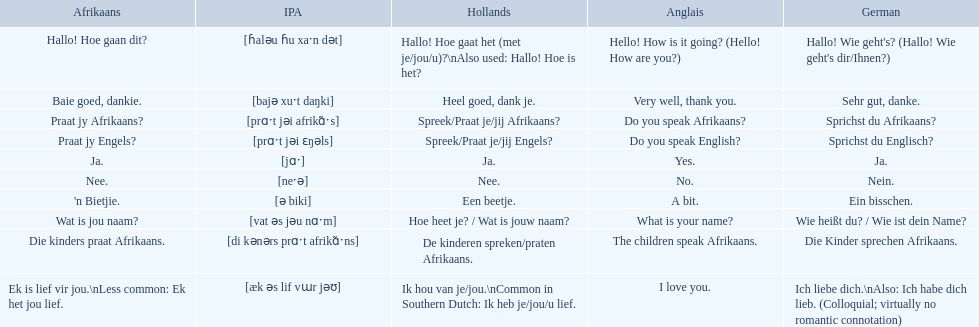Which phrases are said in africaans? Hallo! Hoe gaan dit?, Baie goed, dankie., Praat jy Afrikaans?, Praat jy Engels?, Ja., Nee., 'n Bietjie., Wat is jou naam?, Die kinders praat Afrikaans., Ek is lief vir jou.\nLess common: Ek het jou lief. Which of these mean how do you speak afrikaans? Praat jy Afrikaans?. 